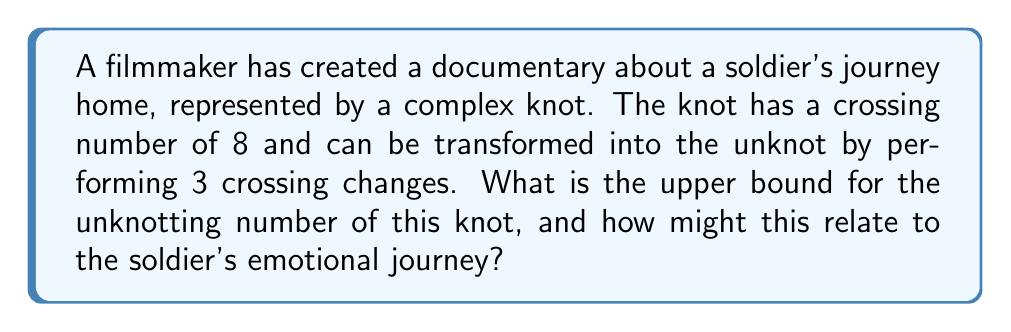Solve this math problem. Let's approach this step-by-step:

1) The unknotting number $u(K)$ of a knot $K$ is defined as the minimum number of crossing changes required to transform the knot into the unknot.

2) We are given that the knot can be transformed into the unknot by 3 crossing changes. This means that:

   $$u(K) \leq 3$$

3) The crossing number $c(K)$ of a knot is the minimum number of crossings in any diagram of the knot. We're given that $c(K) = 8$.

4) There's a well-known relationship between the unknotting number and the crossing number:

   $$u(K) \leq \frac{c(K)}{2}$$

5) In this case:

   $$u(K) \leq \frac{8}{2} = 4$$

6) Therefore, the tighter upper bound for the unknotting number is 3, as we know it can be unknotted with 3 crossing changes.

7) Relating to the soldier's journey: Each crossing change could represent a significant emotional or physical obstacle the soldier must overcome to "unknot" their journey and finally reach home. The fact that there are fewer necessary changes (3) than the total crossings (8) could symbolize that not every challenge needs to be fully resolved for the soldier to complete their journey.
Answer: 3 